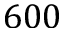Convert formula to latex. <formula><loc_0><loc_0><loc_500><loc_500>6 0 0</formula> 